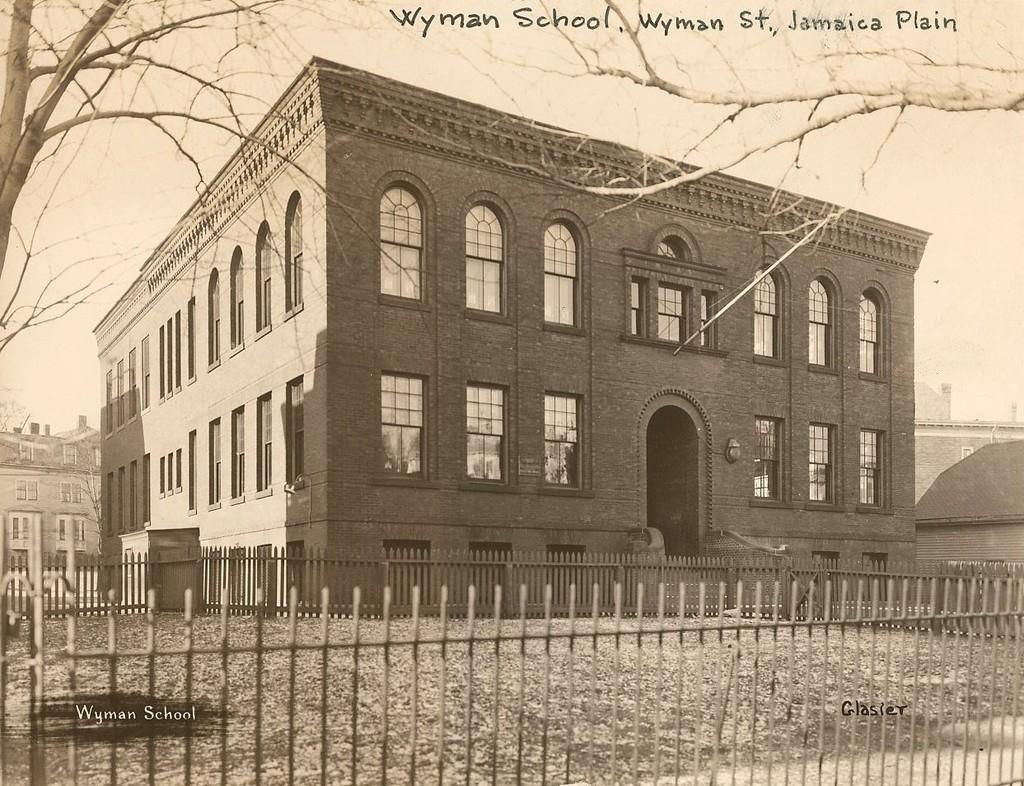Can you describe this image briefly? This is a black and white image. At the bottom of this image I can see the fencing. In the background there are some buildings. At the top I can see trees. At the top of this image I can see some text in black color. 